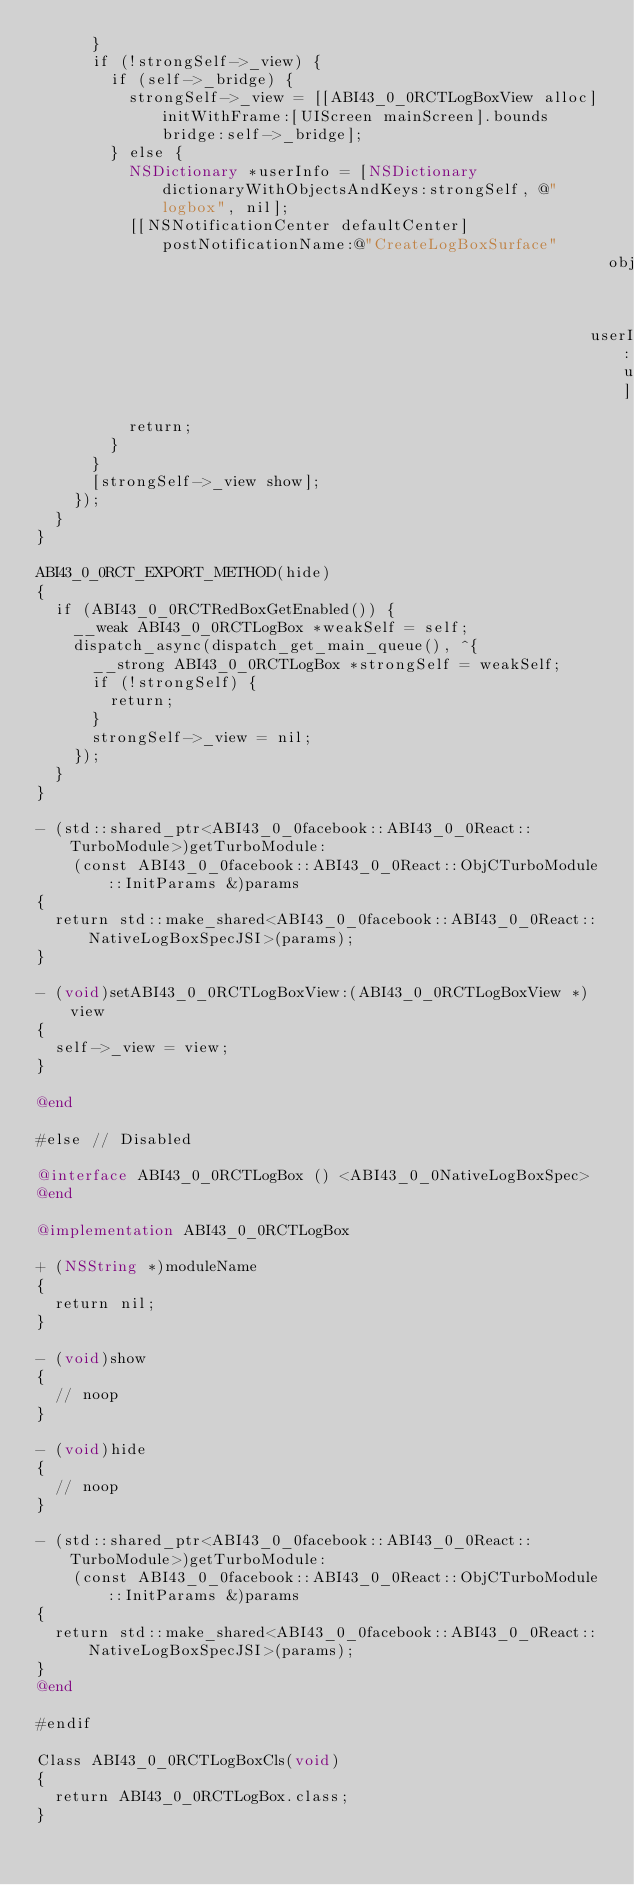<code> <loc_0><loc_0><loc_500><loc_500><_ObjectiveC_>      }
      if (!strongSelf->_view) {
        if (self->_bridge) {
          strongSelf->_view = [[ABI43_0_0RCTLogBoxView alloc] initWithFrame:[UIScreen mainScreen].bounds bridge:self->_bridge];
        } else {
          NSDictionary *userInfo = [NSDictionary dictionaryWithObjectsAndKeys:strongSelf, @"logbox", nil];
          [[NSNotificationCenter defaultCenter] postNotificationName:@"CreateLogBoxSurface"
                                                              object:nil
                                                            userInfo:userInfo];
          return;
        }
      }
      [strongSelf->_view show];
    });
  }
}

ABI43_0_0RCT_EXPORT_METHOD(hide)
{
  if (ABI43_0_0RCTRedBoxGetEnabled()) {
    __weak ABI43_0_0RCTLogBox *weakSelf = self;
    dispatch_async(dispatch_get_main_queue(), ^{
      __strong ABI43_0_0RCTLogBox *strongSelf = weakSelf;
      if (!strongSelf) {
        return;
      }
      strongSelf->_view = nil;
    });
  }
}

- (std::shared_ptr<ABI43_0_0facebook::ABI43_0_0React::TurboModule>)getTurboModule:
    (const ABI43_0_0facebook::ABI43_0_0React::ObjCTurboModule::InitParams &)params
{
  return std::make_shared<ABI43_0_0facebook::ABI43_0_0React::NativeLogBoxSpecJSI>(params);
}

- (void)setABI43_0_0RCTLogBoxView:(ABI43_0_0RCTLogBoxView *)view
{
  self->_view = view;
}

@end

#else // Disabled

@interface ABI43_0_0RCTLogBox () <ABI43_0_0NativeLogBoxSpec>
@end

@implementation ABI43_0_0RCTLogBox

+ (NSString *)moduleName
{
  return nil;
}

- (void)show
{
  // noop
}

- (void)hide
{
  // noop
}

- (std::shared_ptr<ABI43_0_0facebook::ABI43_0_0React::TurboModule>)getTurboModule:
    (const ABI43_0_0facebook::ABI43_0_0React::ObjCTurboModule::InitParams &)params
{
  return std::make_shared<ABI43_0_0facebook::ABI43_0_0React::NativeLogBoxSpecJSI>(params);
}
@end

#endif

Class ABI43_0_0RCTLogBoxCls(void)
{
  return ABI43_0_0RCTLogBox.class;
}
</code> 